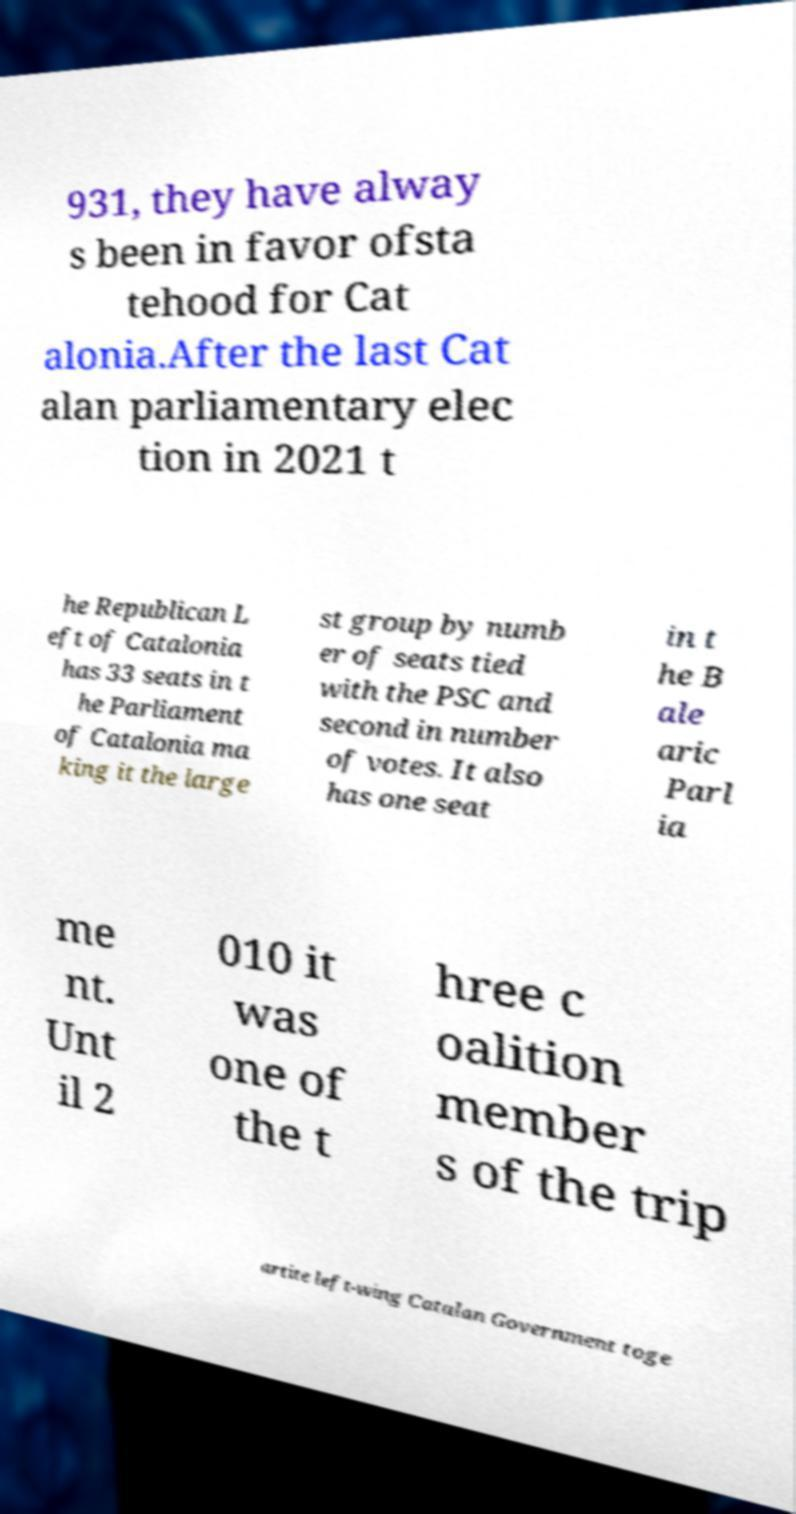I need the written content from this picture converted into text. Can you do that? 931, they have alway s been in favor ofsta tehood for Cat alonia.After the last Cat alan parliamentary elec tion in 2021 t he Republican L eft of Catalonia has 33 seats in t he Parliament of Catalonia ma king it the large st group by numb er of seats tied with the PSC and second in number of votes. It also has one seat in t he B ale aric Parl ia me nt. Unt il 2 010 it was one of the t hree c oalition member s of the trip artite left-wing Catalan Government toge 